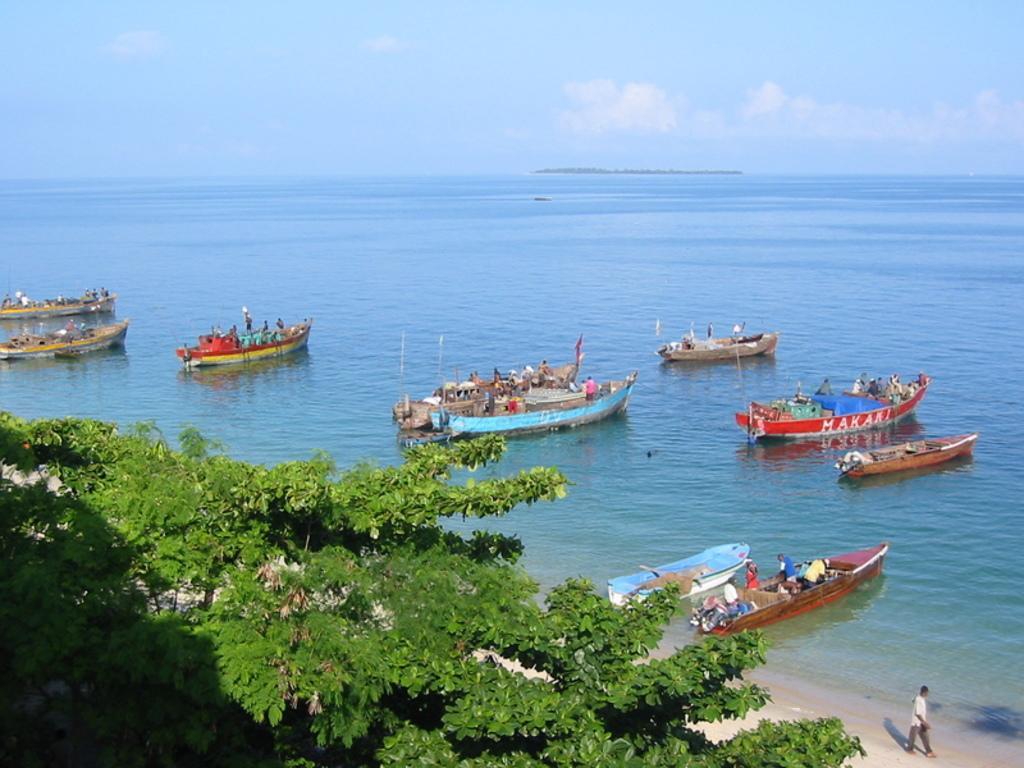How would you summarize this image in a sentence or two? In the image in the center, we can see trees, boats, water, flags, etc.. In the boat, we can see a few people. In the background we can see the sky, clouds and water. 